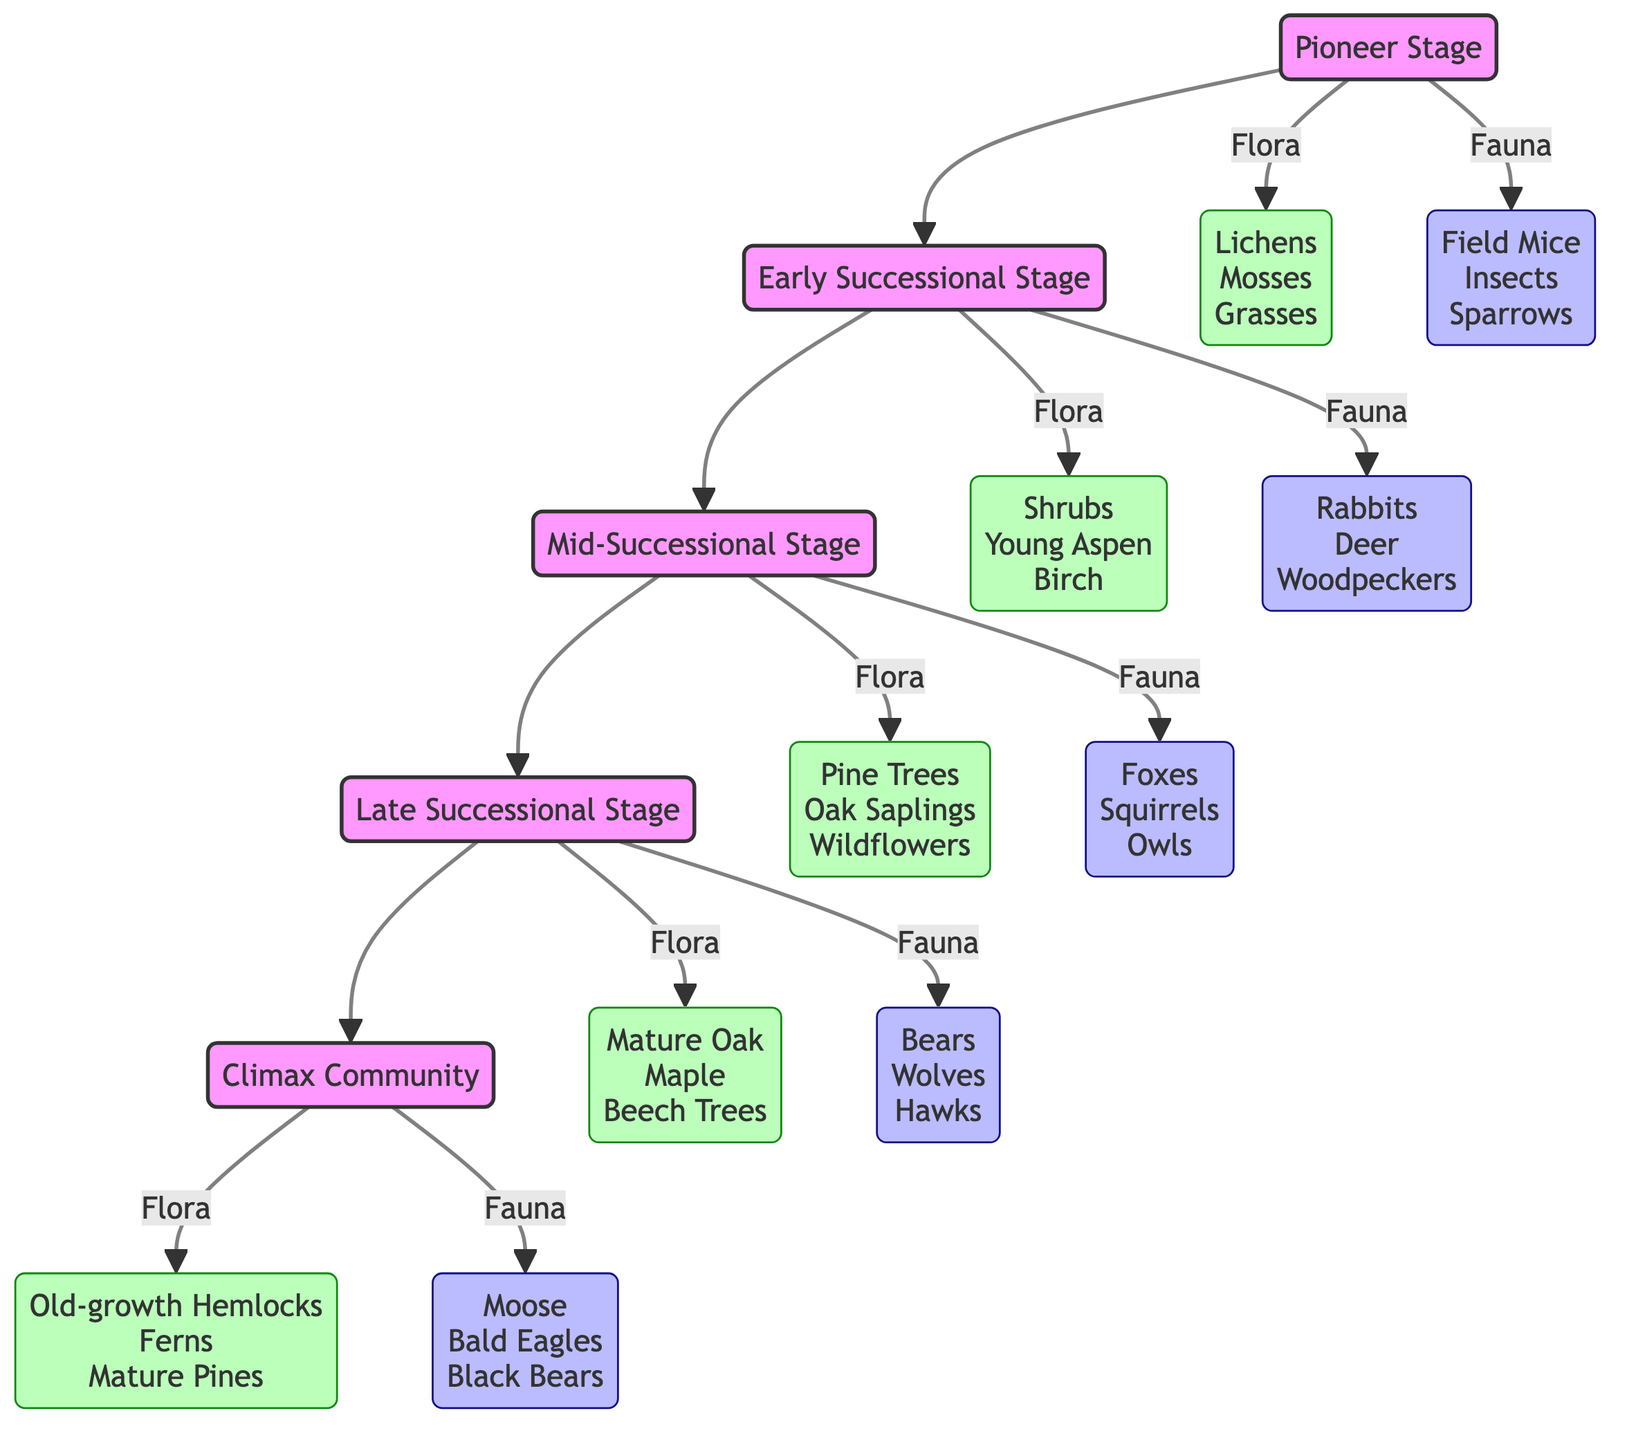What is the first stage of the woodland forest life cycle? The diagram shows the stages of the forest life cycle starting from the Pioneer Stage, which is the first node indicating the beginning of the cycle.
Answer: Pioneer Stage How many stages are depicted in the diagram? By visually counting the stages represented in the flowchart from Pioneer Stage to Climax Community, there are a total of five distinct stages in the life cycle of the woodland forest.
Answer: 5 What types of flora are represented in the Mid-Successional Stage? The Mid-Successional Stage has three flora types listed, specifically Pine Trees, Oak Saplings, and Wildflowers, which are indicated directly under this stage in the diagram.
Answer: Pine Trees, Oak Saplings, Wildflowers Which fauna is associated with the Late Successional Stage? The Late Successional Stage includes three types of fauna, which are Bears, Wolves, and Hawks, as shown in the diagram under this specific stage.
Answer: Bears, Wolves, Hawks What is the relationship between the Early Successional Stage and its associated fauna? The Early Successional Stage is connected to three fauna types: Rabbits, Deer, and Woodpeckers, which illustrate the species that thrive during this stage's growth period in the forest life cycle.
Answer: Rabbits, Deer, Woodpeckers In which stage do Moose appear? Moose are illustrated in the Climax Community stage, indicating that they are part of the species that exist at the peak of the woodland forest's life cycle.
Answer: Climax Community Which flora appears in the Climax Community? The Climax Community stage features three types of flora: Old-growth Hemlocks, Ferns, and Mature Pines, which are explicitly listed under this stage in the diagram.
Answer: Old-growth Hemlocks, Ferns, Mature Pines What is the progression from Pioneer Stage to Late Successional Stage? The progression goes from Pioneer Stage to Early Successional Stage, then to Mid-Successional Stage, followed by Late Successional Stage, forming a clear linear pathway through the diagram.
Answer: Pioneer Stage → Early Successional Stage → Mid-Successional Stage → Late Successional Stage How many types of flora are associated with the Early Successional Stage? The Early Successional Stage is associated with three types of flora, which are indicated as Shrubs, Young Aspen, and Birch under this stage.
Answer: 3 